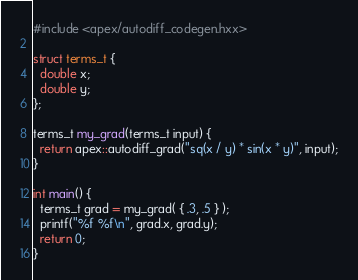<code> <loc_0><loc_0><loc_500><loc_500><_C++_>#include <apex/autodiff_codegen.hxx>

struct terms_t {
  double x;
  double y;
};

terms_t my_grad(terms_t input) {
  return apex::autodiff_grad("sq(x / y) * sin(x * y)", input);
}

int main() {
  terms_t grad = my_grad( { .3, .5 } );
  printf("%f %f\n", grad.x, grad.y);
  return 0;
}</code> 